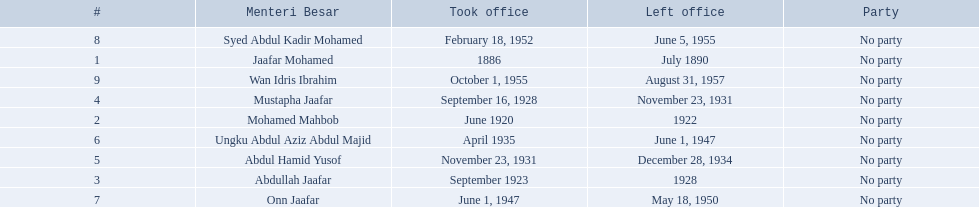When did jaafar mohamed take office? 1886. When did mohamed mahbob take office? June 1920. Who was in office no more than 4 years? Mohamed Mahbob. 